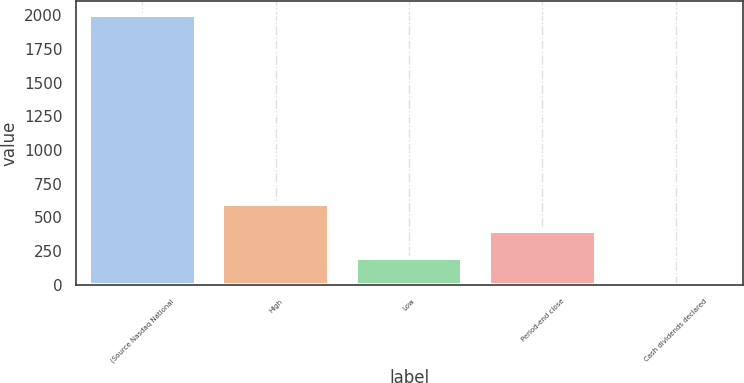Convert chart. <chart><loc_0><loc_0><loc_500><loc_500><bar_chart><fcel>(Source Nasdaq National<fcel>High<fcel>Low<fcel>Period-end close<fcel>Cash dividends declared<nl><fcel>2004<fcel>601.37<fcel>200.63<fcel>401<fcel>0.26<nl></chart> 